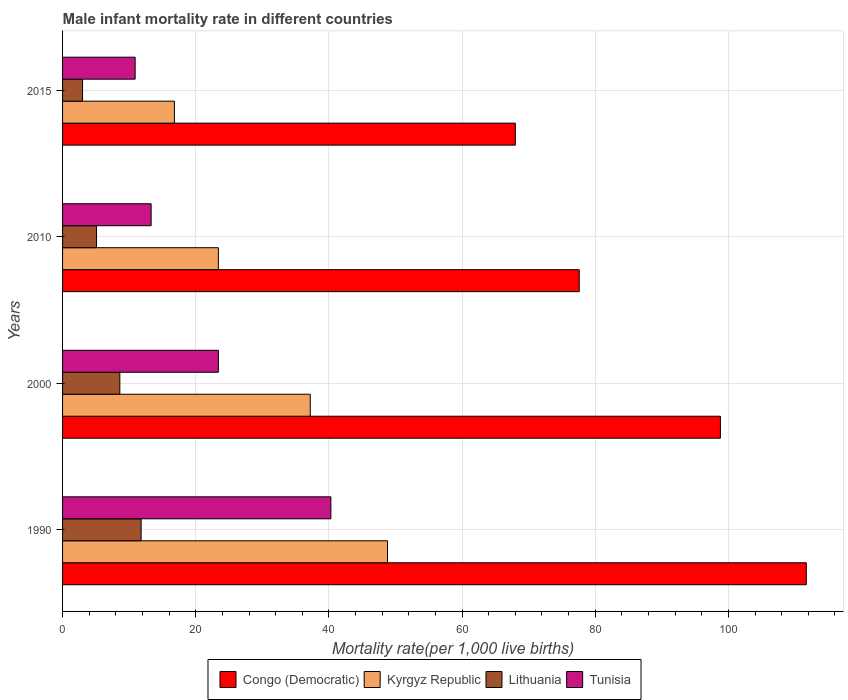How many different coloured bars are there?
Offer a very short reply. 4. Are the number of bars per tick equal to the number of legend labels?
Provide a short and direct response. Yes. Are the number of bars on each tick of the Y-axis equal?
Keep it short and to the point. Yes. How many bars are there on the 2nd tick from the top?
Give a very brief answer. 4. How many bars are there on the 1st tick from the bottom?
Your answer should be very brief. 4. What is the label of the 4th group of bars from the top?
Provide a short and direct response. 1990. What is the male infant mortality rate in Tunisia in 2000?
Offer a terse response. 23.4. Across all years, what is the maximum male infant mortality rate in Congo (Democratic)?
Offer a very short reply. 111.7. Across all years, what is the minimum male infant mortality rate in Kyrgyz Republic?
Give a very brief answer. 16.8. In which year was the male infant mortality rate in Lithuania maximum?
Give a very brief answer. 1990. In which year was the male infant mortality rate in Tunisia minimum?
Provide a short and direct response. 2015. What is the total male infant mortality rate in Kyrgyz Republic in the graph?
Your answer should be very brief. 126.2. What is the difference between the male infant mortality rate in Kyrgyz Republic in 2000 and that in 2015?
Provide a succinct answer. 20.4. What is the difference between the male infant mortality rate in Lithuania in 2000 and the male infant mortality rate in Kyrgyz Republic in 2015?
Offer a very short reply. -8.2. What is the average male infant mortality rate in Lithuania per year?
Keep it short and to the point. 7.12. In the year 1990, what is the difference between the male infant mortality rate in Lithuania and male infant mortality rate in Tunisia?
Your answer should be very brief. -28.5. In how many years, is the male infant mortality rate in Tunisia greater than 28 ?
Keep it short and to the point. 1. Is the male infant mortality rate in Congo (Democratic) in 1990 less than that in 2000?
Offer a terse response. No. Is the difference between the male infant mortality rate in Lithuania in 1990 and 2010 greater than the difference between the male infant mortality rate in Tunisia in 1990 and 2010?
Provide a short and direct response. No. What is the difference between the highest and the second highest male infant mortality rate in Lithuania?
Offer a very short reply. 3.2. What is the difference between the highest and the lowest male infant mortality rate in Tunisia?
Offer a very short reply. 29.4. Is the sum of the male infant mortality rate in Congo (Democratic) in 1990 and 2015 greater than the maximum male infant mortality rate in Kyrgyz Republic across all years?
Provide a succinct answer. Yes. Is it the case that in every year, the sum of the male infant mortality rate in Kyrgyz Republic and male infant mortality rate in Congo (Democratic) is greater than the sum of male infant mortality rate in Tunisia and male infant mortality rate in Lithuania?
Your answer should be very brief. Yes. What does the 3rd bar from the top in 2000 represents?
Give a very brief answer. Kyrgyz Republic. What does the 1st bar from the bottom in 2000 represents?
Provide a short and direct response. Congo (Democratic). How many bars are there?
Offer a very short reply. 16. Are the values on the major ticks of X-axis written in scientific E-notation?
Your answer should be compact. No. Does the graph contain grids?
Make the answer very short. Yes. How are the legend labels stacked?
Provide a short and direct response. Horizontal. What is the title of the graph?
Offer a very short reply. Male infant mortality rate in different countries. What is the label or title of the X-axis?
Ensure brevity in your answer.  Mortality rate(per 1,0 live births). What is the label or title of the Y-axis?
Provide a short and direct response. Years. What is the Mortality rate(per 1,000 live births) in Congo (Democratic) in 1990?
Give a very brief answer. 111.7. What is the Mortality rate(per 1,000 live births) in Kyrgyz Republic in 1990?
Your response must be concise. 48.8. What is the Mortality rate(per 1,000 live births) of Lithuania in 1990?
Provide a succinct answer. 11.8. What is the Mortality rate(per 1,000 live births) of Tunisia in 1990?
Make the answer very short. 40.3. What is the Mortality rate(per 1,000 live births) of Congo (Democratic) in 2000?
Keep it short and to the point. 98.8. What is the Mortality rate(per 1,000 live births) in Kyrgyz Republic in 2000?
Give a very brief answer. 37.2. What is the Mortality rate(per 1,000 live births) of Lithuania in 2000?
Keep it short and to the point. 8.6. What is the Mortality rate(per 1,000 live births) of Tunisia in 2000?
Make the answer very short. 23.4. What is the Mortality rate(per 1,000 live births) of Congo (Democratic) in 2010?
Provide a short and direct response. 77.6. What is the Mortality rate(per 1,000 live births) in Kyrgyz Republic in 2010?
Ensure brevity in your answer.  23.4. What is the Mortality rate(per 1,000 live births) in Lithuania in 2010?
Offer a very short reply. 5.1. What is the Mortality rate(per 1,000 live births) in Tunisia in 2010?
Offer a very short reply. 13.3. What is the Mortality rate(per 1,000 live births) of Tunisia in 2015?
Offer a terse response. 10.9. Across all years, what is the maximum Mortality rate(per 1,000 live births) in Congo (Democratic)?
Offer a terse response. 111.7. Across all years, what is the maximum Mortality rate(per 1,000 live births) of Kyrgyz Republic?
Keep it short and to the point. 48.8. Across all years, what is the maximum Mortality rate(per 1,000 live births) in Lithuania?
Keep it short and to the point. 11.8. Across all years, what is the maximum Mortality rate(per 1,000 live births) of Tunisia?
Offer a very short reply. 40.3. Across all years, what is the minimum Mortality rate(per 1,000 live births) in Kyrgyz Republic?
Offer a very short reply. 16.8. Across all years, what is the minimum Mortality rate(per 1,000 live births) of Lithuania?
Make the answer very short. 3. What is the total Mortality rate(per 1,000 live births) of Congo (Democratic) in the graph?
Your response must be concise. 356.1. What is the total Mortality rate(per 1,000 live births) of Kyrgyz Republic in the graph?
Give a very brief answer. 126.2. What is the total Mortality rate(per 1,000 live births) of Lithuania in the graph?
Provide a succinct answer. 28.5. What is the total Mortality rate(per 1,000 live births) of Tunisia in the graph?
Give a very brief answer. 87.9. What is the difference between the Mortality rate(per 1,000 live births) of Kyrgyz Republic in 1990 and that in 2000?
Your response must be concise. 11.6. What is the difference between the Mortality rate(per 1,000 live births) of Congo (Democratic) in 1990 and that in 2010?
Keep it short and to the point. 34.1. What is the difference between the Mortality rate(per 1,000 live births) of Kyrgyz Republic in 1990 and that in 2010?
Give a very brief answer. 25.4. What is the difference between the Mortality rate(per 1,000 live births) of Lithuania in 1990 and that in 2010?
Your response must be concise. 6.7. What is the difference between the Mortality rate(per 1,000 live births) in Congo (Democratic) in 1990 and that in 2015?
Ensure brevity in your answer.  43.7. What is the difference between the Mortality rate(per 1,000 live births) in Kyrgyz Republic in 1990 and that in 2015?
Ensure brevity in your answer.  32. What is the difference between the Mortality rate(per 1,000 live births) of Lithuania in 1990 and that in 2015?
Offer a terse response. 8.8. What is the difference between the Mortality rate(per 1,000 live births) in Tunisia in 1990 and that in 2015?
Offer a very short reply. 29.4. What is the difference between the Mortality rate(per 1,000 live births) of Congo (Democratic) in 2000 and that in 2010?
Offer a terse response. 21.2. What is the difference between the Mortality rate(per 1,000 live births) in Tunisia in 2000 and that in 2010?
Your answer should be very brief. 10.1. What is the difference between the Mortality rate(per 1,000 live births) of Congo (Democratic) in 2000 and that in 2015?
Give a very brief answer. 30.8. What is the difference between the Mortality rate(per 1,000 live births) of Kyrgyz Republic in 2000 and that in 2015?
Offer a terse response. 20.4. What is the difference between the Mortality rate(per 1,000 live births) of Lithuania in 2000 and that in 2015?
Give a very brief answer. 5.6. What is the difference between the Mortality rate(per 1,000 live births) in Tunisia in 2000 and that in 2015?
Your response must be concise. 12.5. What is the difference between the Mortality rate(per 1,000 live births) of Congo (Democratic) in 2010 and that in 2015?
Your answer should be very brief. 9.6. What is the difference between the Mortality rate(per 1,000 live births) in Kyrgyz Republic in 2010 and that in 2015?
Your response must be concise. 6.6. What is the difference between the Mortality rate(per 1,000 live births) of Lithuania in 2010 and that in 2015?
Ensure brevity in your answer.  2.1. What is the difference between the Mortality rate(per 1,000 live births) in Congo (Democratic) in 1990 and the Mortality rate(per 1,000 live births) in Kyrgyz Republic in 2000?
Your answer should be compact. 74.5. What is the difference between the Mortality rate(per 1,000 live births) in Congo (Democratic) in 1990 and the Mortality rate(per 1,000 live births) in Lithuania in 2000?
Make the answer very short. 103.1. What is the difference between the Mortality rate(per 1,000 live births) of Congo (Democratic) in 1990 and the Mortality rate(per 1,000 live births) of Tunisia in 2000?
Your answer should be compact. 88.3. What is the difference between the Mortality rate(per 1,000 live births) in Kyrgyz Republic in 1990 and the Mortality rate(per 1,000 live births) in Lithuania in 2000?
Your response must be concise. 40.2. What is the difference between the Mortality rate(per 1,000 live births) of Kyrgyz Republic in 1990 and the Mortality rate(per 1,000 live births) of Tunisia in 2000?
Provide a succinct answer. 25.4. What is the difference between the Mortality rate(per 1,000 live births) in Lithuania in 1990 and the Mortality rate(per 1,000 live births) in Tunisia in 2000?
Provide a succinct answer. -11.6. What is the difference between the Mortality rate(per 1,000 live births) of Congo (Democratic) in 1990 and the Mortality rate(per 1,000 live births) of Kyrgyz Republic in 2010?
Offer a terse response. 88.3. What is the difference between the Mortality rate(per 1,000 live births) in Congo (Democratic) in 1990 and the Mortality rate(per 1,000 live births) in Lithuania in 2010?
Ensure brevity in your answer.  106.6. What is the difference between the Mortality rate(per 1,000 live births) in Congo (Democratic) in 1990 and the Mortality rate(per 1,000 live births) in Tunisia in 2010?
Provide a succinct answer. 98.4. What is the difference between the Mortality rate(per 1,000 live births) of Kyrgyz Republic in 1990 and the Mortality rate(per 1,000 live births) of Lithuania in 2010?
Make the answer very short. 43.7. What is the difference between the Mortality rate(per 1,000 live births) of Kyrgyz Republic in 1990 and the Mortality rate(per 1,000 live births) of Tunisia in 2010?
Provide a short and direct response. 35.5. What is the difference between the Mortality rate(per 1,000 live births) of Lithuania in 1990 and the Mortality rate(per 1,000 live births) of Tunisia in 2010?
Keep it short and to the point. -1.5. What is the difference between the Mortality rate(per 1,000 live births) in Congo (Democratic) in 1990 and the Mortality rate(per 1,000 live births) in Kyrgyz Republic in 2015?
Provide a short and direct response. 94.9. What is the difference between the Mortality rate(per 1,000 live births) of Congo (Democratic) in 1990 and the Mortality rate(per 1,000 live births) of Lithuania in 2015?
Your answer should be compact. 108.7. What is the difference between the Mortality rate(per 1,000 live births) of Congo (Democratic) in 1990 and the Mortality rate(per 1,000 live births) of Tunisia in 2015?
Keep it short and to the point. 100.8. What is the difference between the Mortality rate(per 1,000 live births) of Kyrgyz Republic in 1990 and the Mortality rate(per 1,000 live births) of Lithuania in 2015?
Keep it short and to the point. 45.8. What is the difference between the Mortality rate(per 1,000 live births) of Kyrgyz Republic in 1990 and the Mortality rate(per 1,000 live births) of Tunisia in 2015?
Keep it short and to the point. 37.9. What is the difference between the Mortality rate(per 1,000 live births) of Lithuania in 1990 and the Mortality rate(per 1,000 live births) of Tunisia in 2015?
Give a very brief answer. 0.9. What is the difference between the Mortality rate(per 1,000 live births) in Congo (Democratic) in 2000 and the Mortality rate(per 1,000 live births) in Kyrgyz Republic in 2010?
Give a very brief answer. 75.4. What is the difference between the Mortality rate(per 1,000 live births) of Congo (Democratic) in 2000 and the Mortality rate(per 1,000 live births) of Lithuania in 2010?
Your answer should be compact. 93.7. What is the difference between the Mortality rate(per 1,000 live births) in Congo (Democratic) in 2000 and the Mortality rate(per 1,000 live births) in Tunisia in 2010?
Make the answer very short. 85.5. What is the difference between the Mortality rate(per 1,000 live births) of Kyrgyz Republic in 2000 and the Mortality rate(per 1,000 live births) of Lithuania in 2010?
Your response must be concise. 32.1. What is the difference between the Mortality rate(per 1,000 live births) in Kyrgyz Republic in 2000 and the Mortality rate(per 1,000 live births) in Tunisia in 2010?
Offer a terse response. 23.9. What is the difference between the Mortality rate(per 1,000 live births) of Congo (Democratic) in 2000 and the Mortality rate(per 1,000 live births) of Kyrgyz Republic in 2015?
Give a very brief answer. 82. What is the difference between the Mortality rate(per 1,000 live births) of Congo (Democratic) in 2000 and the Mortality rate(per 1,000 live births) of Lithuania in 2015?
Your answer should be very brief. 95.8. What is the difference between the Mortality rate(per 1,000 live births) of Congo (Democratic) in 2000 and the Mortality rate(per 1,000 live births) of Tunisia in 2015?
Offer a terse response. 87.9. What is the difference between the Mortality rate(per 1,000 live births) in Kyrgyz Republic in 2000 and the Mortality rate(per 1,000 live births) in Lithuania in 2015?
Offer a terse response. 34.2. What is the difference between the Mortality rate(per 1,000 live births) of Kyrgyz Republic in 2000 and the Mortality rate(per 1,000 live births) of Tunisia in 2015?
Offer a terse response. 26.3. What is the difference between the Mortality rate(per 1,000 live births) in Lithuania in 2000 and the Mortality rate(per 1,000 live births) in Tunisia in 2015?
Give a very brief answer. -2.3. What is the difference between the Mortality rate(per 1,000 live births) of Congo (Democratic) in 2010 and the Mortality rate(per 1,000 live births) of Kyrgyz Republic in 2015?
Give a very brief answer. 60.8. What is the difference between the Mortality rate(per 1,000 live births) in Congo (Democratic) in 2010 and the Mortality rate(per 1,000 live births) in Lithuania in 2015?
Your response must be concise. 74.6. What is the difference between the Mortality rate(per 1,000 live births) of Congo (Democratic) in 2010 and the Mortality rate(per 1,000 live births) of Tunisia in 2015?
Give a very brief answer. 66.7. What is the difference between the Mortality rate(per 1,000 live births) of Kyrgyz Republic in 2010 and the Mortality rate(per 1,000 live births) of Lithuania in 2015?
Keep it short and to the point. 20.4. What is the average Mortality rate(per 1,000 live births) of Congo (Democratic) per year?
Provide a succinct answer. 89.03. What is the average Mortality rate(per 1,000 live births) in Kyrgyz Republic per year?
Your answer should be very brief. 31.55. What is the average Mortality rate(per 1,000 live births) in Lithuania per year?
Give a very brief answer. 7.12. What is the average Mortality rate(per 1,000 live births) in Tunisia per year?
Provide a short and direct response. 21.98. In the year 1990, what is the difference between the Mortality rate(per 1,000 live births) of Congo (Democratic) and Mortality rate(per 1,000 live births) of Kyrgyz Republic?
Provide a succinct answer. 62.9. In the year 1990, what is the difference between the Mortality rate(per 1,000 live births) in Congo (Democratic) and Mortality rate(per 1,000 live births) in Lithuania?
Ensure brevity in your answer.  99.9. In the year 1990, what is the difference between the Mortality rate(per 1,000 live births) of Congo (Democratic) and Mortality rate(per 1,000 live births) of Tunisia?
Keep it short and to the point. 71.4. In the year 1990, what is the difference between the Mortality rate(per 1,000 live births) of Lithuania and Mortality rate(per 1,000 live births) of Tunisia?
Your response must be concise. -28.5. In the year 2000, what is the difference between the Mortality rate(per 1,000 live births) of Congo (Democratic) and Mortality rate(per 1,000 live births) of Kyrgyz Republic?
Make the answer very short. 61.6. In the year 2000, what is the difference between the Mortality rate(per 1,000 live births) in Congo (Democratic) and Mortality rate(per 1,000 live births) in Lithuania?
Provide a succinct answer. 90.2. In the year 2000, what is the difference between the Mortality rate(per 1,000 live births) in Congo (Democratic) and Mortality rate(per 1,000 live births) in Tunisia?
Provide a succinct answer. 75.4. In the year 2000, what is the difference between the Mortality rate(per 1,000 live births) in Kyrgyz Republic and Mortality rate(per 1,000 live births) in Lithuania?
Your answer should be very brief. 28.6. In the year 2000, what is the difference between the Mortality rate(per 1,000 live births) in Kyrgyz Republic and Mortality rate(per 1,000 live births) in Tunisia?
Your answer should be very brief. 13.8. In the year 2000, what is the difference between the Mortality rate(per 1,000 live births) in Lithuania and Mortality rate(per 1,000 live births) in Tunisia?
Provide a succinct answer. -14.8. In the year 2010, what is the difference between the Mortality rate(per 1,000 live births) in Congo (Democratic) and Mortality rate(per 1,000 live births) in Kyrgyz Republic?
Your answer should be very brief. 54.2. In the year 2010, what is the difference between the Mortality rate(per 1,000 live births) of Congo (Democratic) and Mortality rate(per 1,000 live births) of Lithuania?
Make the answer very short. 72.5. In the year 2010, what is the difference between the Mortality rate(per 1,000 live births) in Congo (Democratic) and Mortality rate(per 1,000 live births) in Tunisia?
Your answer should be very brief. 64.3. In the year 2015, what is the difference between the Mortality rate(per 1,000 live births) in Congo (Democratic) and Mortality rate(per 1,000 live births) in Kyrgyz Republic?
Provide a short and direct response. 51.2. In the year 2015, what is the difference between the Mortality rate(per 1,000 live births) of Congo (Democratic) and Mortality rate(per 1,000 live births) of Tunisia?
Give a very brief answer. 57.1. In the year 2015, what is the difference between the Mortality rate(per 1,000 live births) in Kyrgyz Republic and Mortality rate(per 1,000 live births) in Tunisia?
Provide a succinct answer. 5.9. What is the ratio of the Mortality rate(per 1,000 live births) of Congo (Democratic) in 1990 to that in 2000?
Your answer should be compact. 1.13. What is the ratio of the Mortality rate(per 1,000 live births) in Kyrgyz Republic in 1990 to that in 2000?
Give a very brief answer. 1.31. What is the ratio of the Mortality rate(per 1,000 live births) of Lithuania in 1990 to that in 2000?
Give a very brief answer. 1.37. What is the ratio of the Mortality rate(per 1,000 live births) of Tunisia in 1990 to that in 2000?
Your response must be concise. 1.72. What is the ratio of the Mortality rate(per 1,000 live births) of Congo (Democratic) in 1990 to that in 2010?
Provide a short and direct response. 1.44. What is the ratio of the Mortality rate(per 1,000 live births) of Kyrgyz Republic in 1990 to that in 2010?
Ensure brevity in your answer.  2.09. What is the ratio of the Mortality rate(per 1,000 live births) of Lithuania in 1990 to that in 2010?
Ensure brevity in your answer.  2.31. What is the ratio of the Mortality rate(per 1,000 live births) in Tunisia in 1990 to that in 2010?
Your answer should be very brief. 3.03. What is the ratio of the Mortality rate(per 1,000 live births) in Congo (Democratic) in 1990 to that in 2015?
Provide a short and direct response. 1.64. What is the ratio of the Mortality rate(per 1,000 live births) in Kyrgyz Republic in 1990 to that in 2015?
Your answer should be very brief. 2.9. What is the ratio of the Mortality rate(per 1,000 live births) in Lithuania in 1990 to that in 2015?
Offer a terse response. 3.93. What is the ratio of the Mortality rate(per 1,000 live births) of Tunisia in 1990 to that in 2015?
Provide a short and direct response. 3.7. What is the ratio of the Mortality rate(per 1,000 live births) in Congo (Democratic) in 2000 to that in 2010?
Provide a succinct answer. 1.27. What is the ratio of the Mortality rate(per 1,000 live births) in Kyrgyz Republic in 2000 to that in 2010?
Provide a short and direct response. 1.59. What is the ratio of the Mortality rate(per 1,000 live births) of Lithuania in 2000 to that in 2010?
Offer a terse response. 1.69. What is the ratio of the Mortality rate(per 1,000 live births) of Tunisia in 2000 to that in 2010?
Ensure brevity in your answer.  1.76. What is the ratio of the Mortality rate(per 1,000 live births) in Congo (Democratic) in 2000 to that in 2015?
Ensure brevity in your answer.  1.45. What is the ratio of the Mortality rate(per 1,000 live births) in Kyrgyz Republic in 2000 to that in 2015?
Your answer should be very brief. 2.21. What is the ratio of the Mortality rate(per 1,000 live births) of Lithuania in 2000 to that in 2015?
Your answer should be compact. 2.87. What is the ratio of the Mortality rate(per 1,000 live births) in Tunisia in 2000 to that in 2015?
Make the answer very short. 2.15. What is the ratio of the Mortality rate(per 1,000 live births) of Congo (Democratic) in 2010 to that in 2015?
Offer a terse response. 1.14. What is the ratio of the Mortality rate(per 1,000 live births) of Kyrgyz Republic in 2010 to that in 2015?
Keep it short and to the point. 1.39. What is the ratio of the Mortality rate(per 1,000 live births) of Lithuania in 2010 to that in 2015?
Your response must be concise. 1.7. What is the ratio of the Mortality rate(per 1,000 live births) in Tunisia in 2010 to that in 2015?
Offer a terse response. 1.22. What is the difference between the highest and the second highest Mortality rate(per 1,000 live births) in Kyrgyz Republic?
Your answer should be compact. 11.6. What is the difference between the highest and the lowest Mortality rate(per 1,000 live births) of Congo (Democratic)?
Provide a short and direct response. 43.7. What is the difference between the highest and the lowest Mortality rate(per 1,000 live births) in Tunisia?
Ensure brevity in your answer.  29.4. 